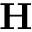Convert formula to latex. <formula><loc_0><loc_0><loc_500><loc_500>{ H }</formula> 